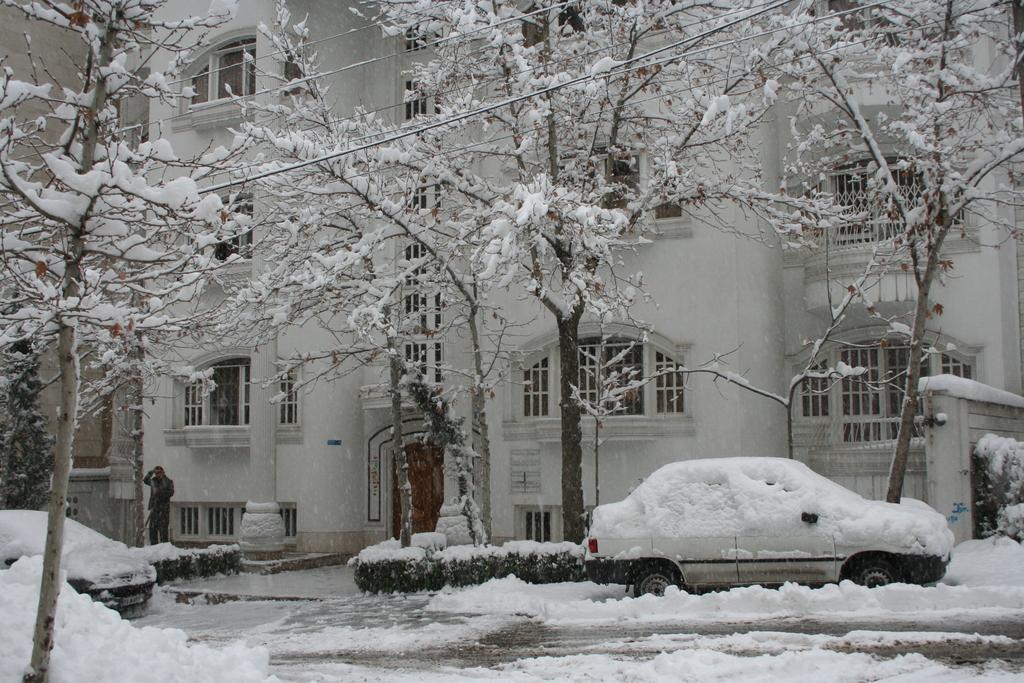Please provide a concise description of this image. In this picture I can observe some snow on the land. there is a car on the right side. In this picture I can observe some trees. In the background there is a building which is in white color. 